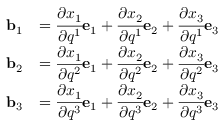Convert formula to latex. <formula><loc_0><loc_0><loc_500><loc_500>{ \begin{array} { r l } { b _ { 1 } } & { = { \cfrac { \partial x _ { 1 } } { \partial q ^ { 1 } } } e _ { 1 } + { \cfrac { \partial x _ { 2 } } { \partial q ^ { 1 } } } e _ { 2 } + { \cfrac { \partial x _ { 3 } } { \partial q ^ { 1 } } } e _ { 3 } } \\ { b _ { 2 } } & { = { \cfrac { \partial x _ { 1 } } { \partial q ^ { 2 } } } e _ { 1 } + { \cfrac { \partial x _ { 2 } } { \partial q ^ { 2 } } } e _ { 2 } + { \cfrac { \partial x _ { 3 } } { \partial q ^ { 2 } } } e _ { 3 } } \\ { b _ { 3 } } & { = { \cfrac { \partial x _ { 1 } } { \partial q ^ { 3 } } } e _ { 1 } + { \cfrac { \partial x _ { 2 } } { \partial q ^ { 3 } } } e _ { 2 } + { \cfrac { \partial x _ { 3 } } { \partial q ^ { 3 } } } e _ { 3 } } \end{array} }</formula> 